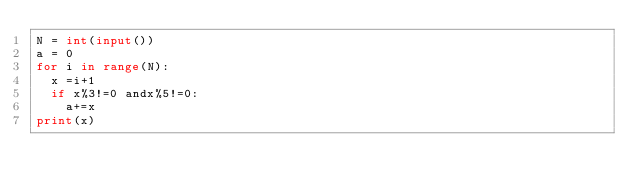Convert code to text. <code><loc_0><loc_0><loc_500><loc_500><_Python_>N = int(input())
a = 0
for i in range(N):
  x =i+1
  if x%3!=0 andx%5!=0:
    a+=x
print(x)</code> 